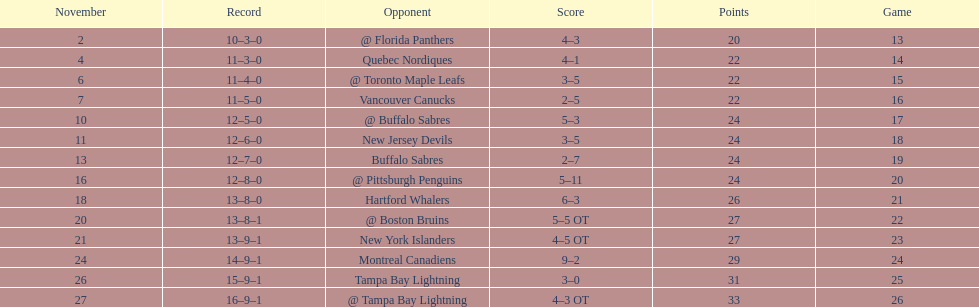What was the total penalty minutes that dave brown had on the 1993-1994 flyers? 137. 